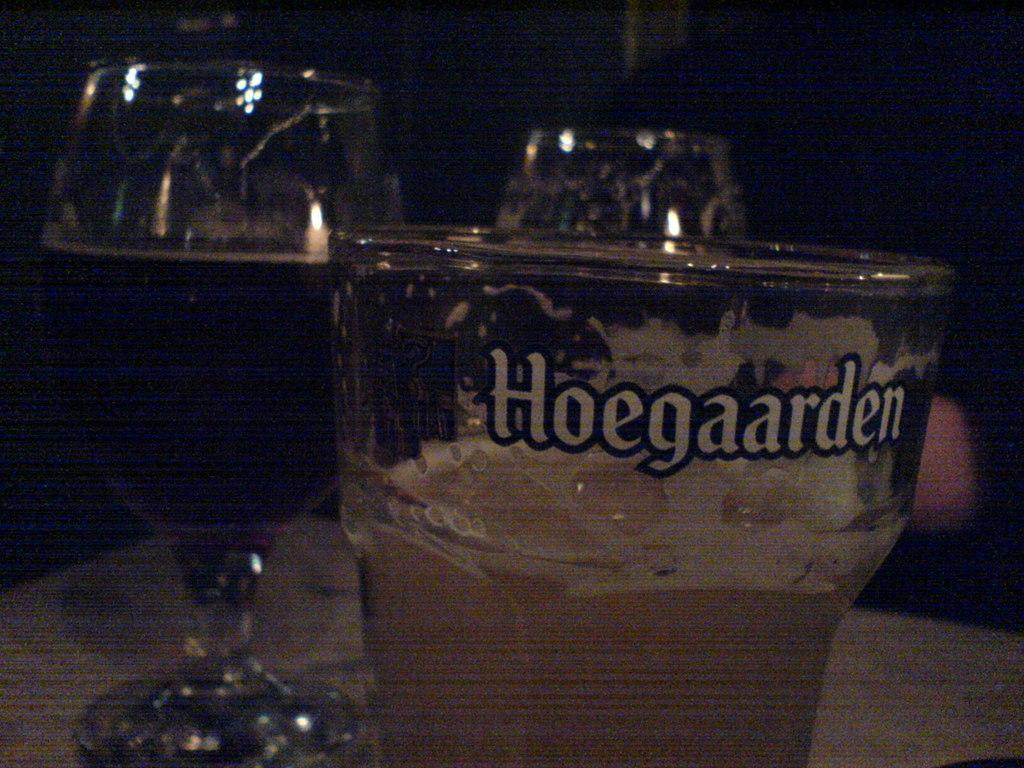Provide a one-sentence caption for the provided image. A shaken mixed liquor drink in a glass marked Hoegaarden. 